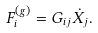Convert formula to latex. <formula><loc_0><loc_0><loc_500><loc_500>F _ { i } ^ { ( g ) } = G _ { i j } \dot { X } _ { j } .</formula> 